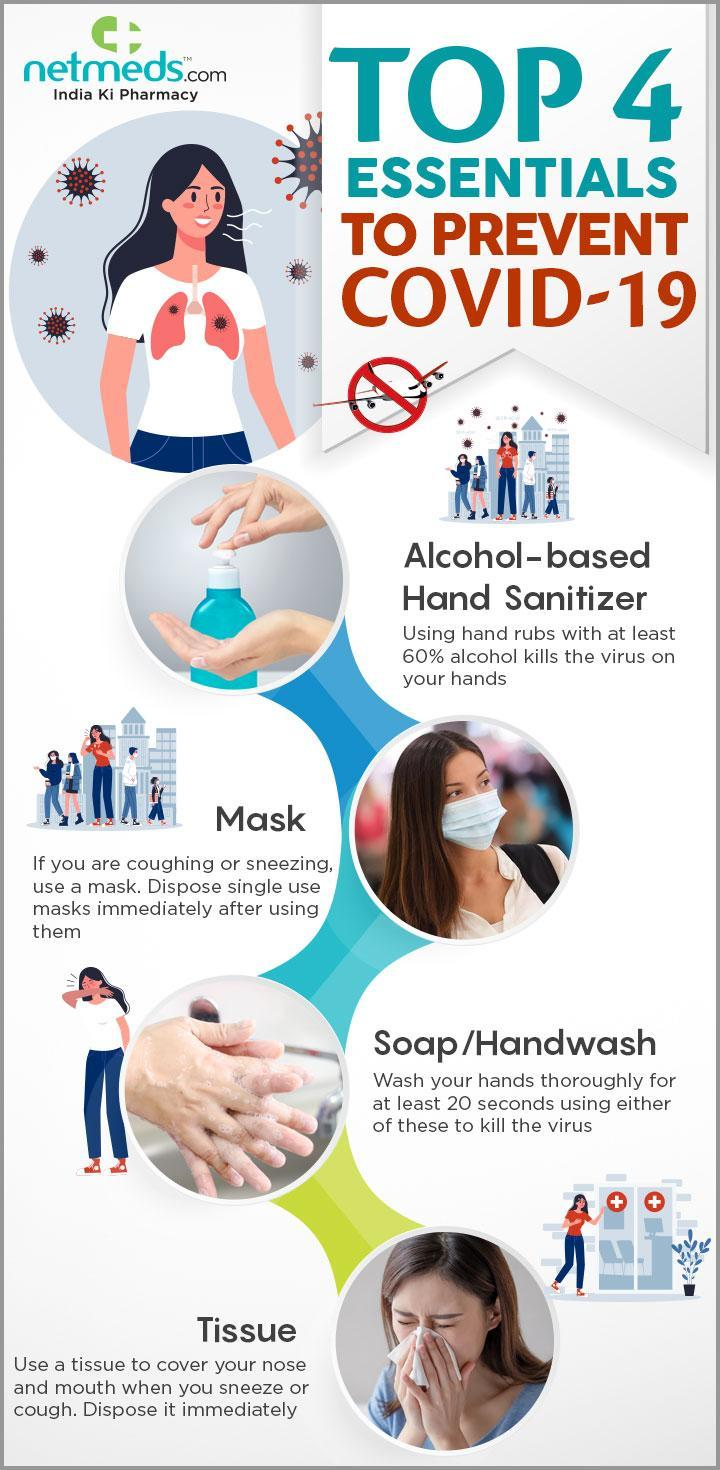What should be done with the tissue right after coughing or sneezing?
Answer the question with a short phrase. Dispose it immediately 